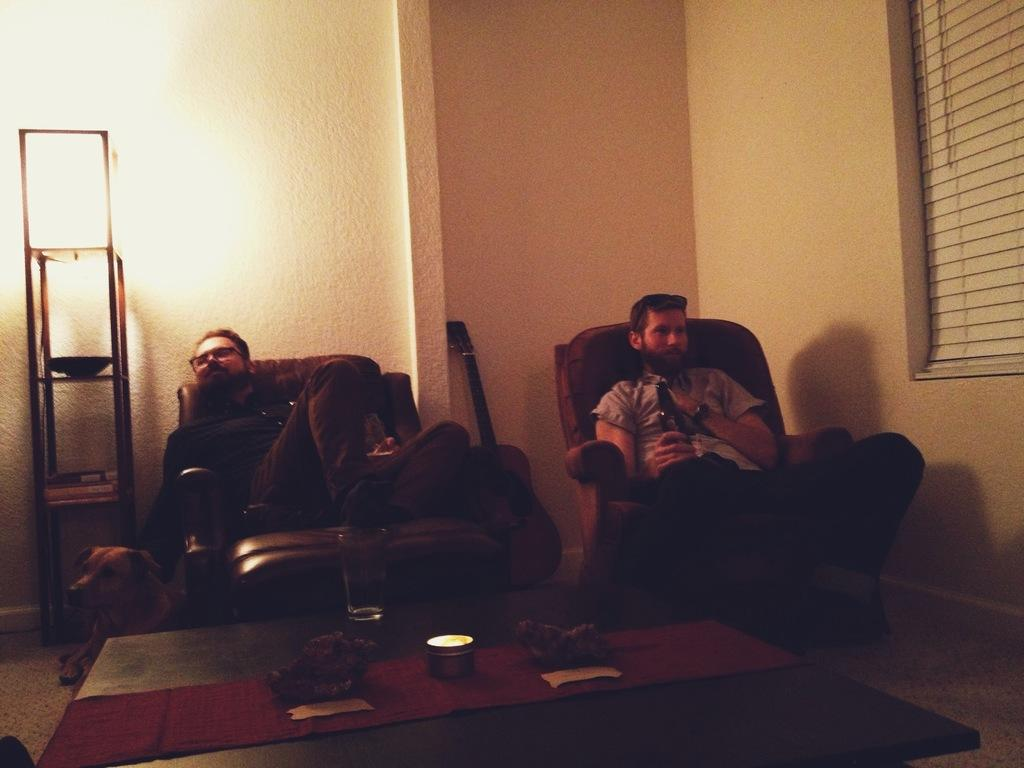How many people are sitting on the sofa in the image? There are two people sitting on the sofa in the image. What object is resting on the wall at the center of the image? There is a guitar resting on the wall at the center of the image. What animal is sitting on the floor at the left side of the image? There is a dog sitting on the floor at the left side of the image. Can you see any waves in the image? There are no waves present in the image. What type of lead is the dog using to play the guitar in the image? The image does not show the dog playing the guitar, and there is no mention of any lead. 